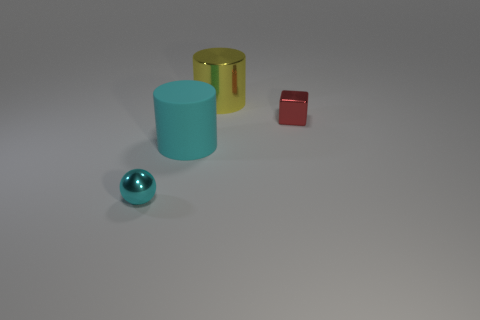There is a big cyan matte object; what shape is it?
Your answer should be compact. Cylinder. There is a thing that is the same size as the shiny cylinder; what is its material?
Offer a very short reply. Rubber. There is a small thing in front of the tiny red metallic block; does it have the same color as the rubber cylinder in front of the large yellow metallic thing?
Provide a short and direct response. Yes. Are there any other large cyan objects that have the same shape as the big metallic thing?
Give a very brief answer. Yes. What shape is the rubber object that is the same size as the shiny cylinder?
Offer a terse response. Cylinder. What number of objects are the same color as the big rubber cylinder?
Offer a very short reply. 1. What is the size of the matte cylinder that is behind the sphere?
Provide a succinct answer. Large. How many cyan rubber cylinders have the same size as the cyan ball?
Provide a succinct answer. 0. There is a ball that is made of the same material as the tiny block; what color is it?
Provide a succinct answer. Cyan. Is the number of cylinders right of the red object less than the number of large cyan matte cylinders?
Offer a very short reply. Yes. 